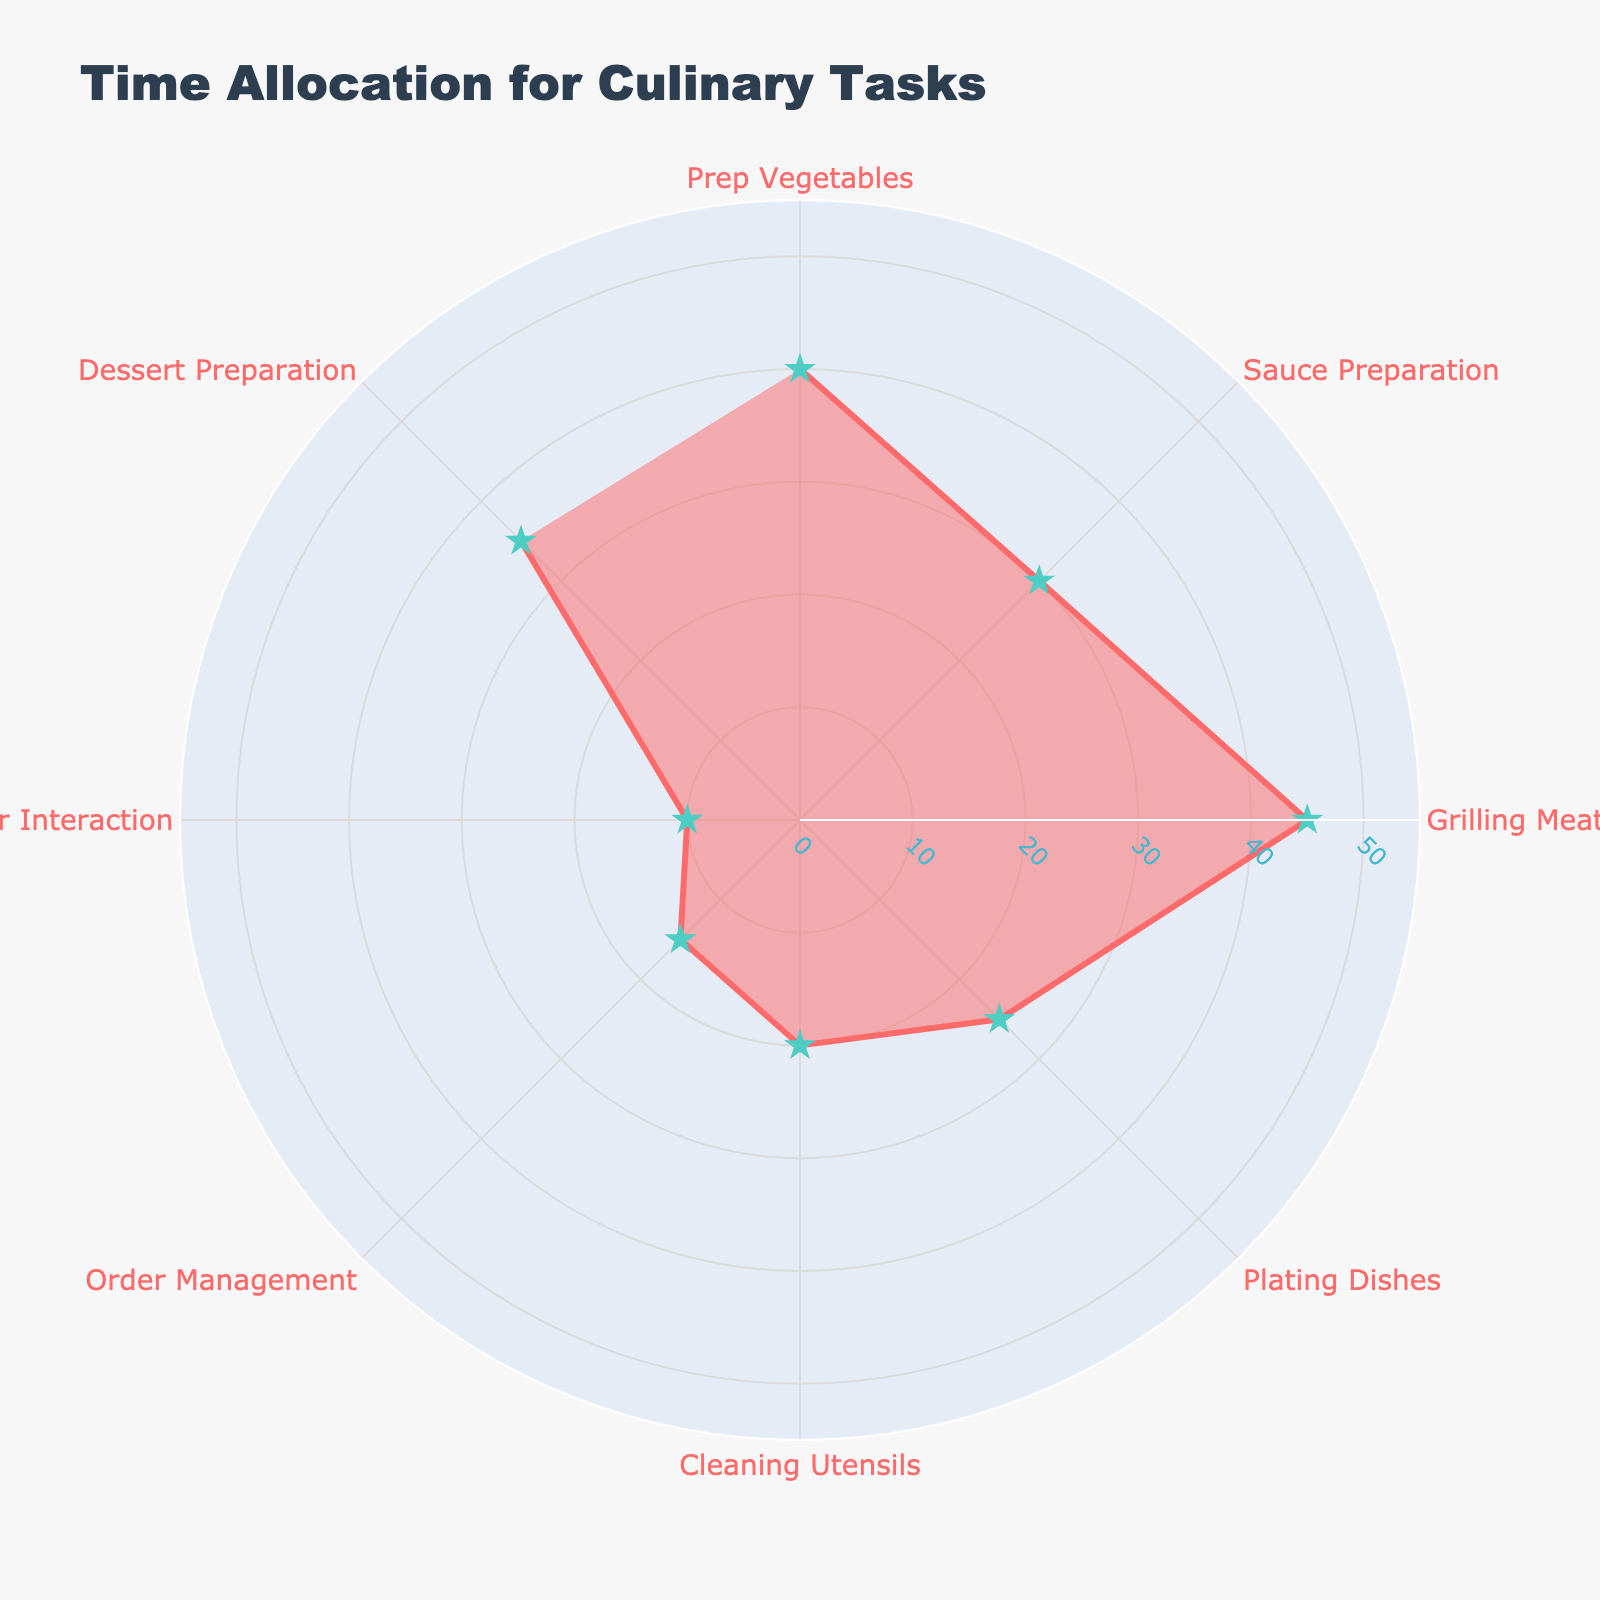What's the title of the chart? The title is always displayed at the top of the chart. In this case, it shows "Time Allocation for Culinary Tasks".
Answer: Time Allocation for Culinary Tasks Which task takes the longest amount of time? The Polar Chart will show the distances from the center, and the task with the longest distance from the center represents the highest time. "Grilling Meat" is the task farthest from the center.
Answer: Grilling Meat How many tasks are represented in the figure? Count the distinct segments or points on the chart, as each one represents a different task. There are 8 tasks shown.
Answer: 8 What is the time allocated for dessert preparation? Refer to the specific point representing "Dessert Preparation" on the chart which shows the radial distance. It is 35 minutes.
Answer: 35 minutes What is the average time spent on 'Prep Vegetables' and 'Cleaning Utensils'? Add the times for 'Prep Vegetables' (40 minutes) and 'Cleaning Utensils' (20 minutes), then divide by 2. The average is (40 + 20) / 2 = 30 minutes.
Answer: 30 minutes Which task takes less time than 'Plating Dishes' but more time than 'Customer Interaction'? Identify the tasks whose times are in between 'Plating Dishes' (25 minutes) and 'Customer Interaction' (10 minutes). 'Order Management' is the task that fits this criterion with 15 minutes.
Answer: Order Management What is the combined time spent on 'Sauce Preparation' and 'Dessert Preparation'? Add the times for 'Sauce Preparation' (30 minutes) and 'Dessert Preparation' (35 minutes). The sum is 30 + 35 = 65 minutes.
Answer: 65 minutes Which task takes exactly 45 minutes? Look for the point that lies on the circle marking 45 minutes. The task corresponding to this point will be 'Grilling Meat'.
Answer: Grilling Meat Which is shorter in duration: order management or customer interaction? Compare the radial distances for 'Order Management' (15 minutes) and 'Customer Interaction' (10 minutes). 'Customer Interaction' is shorter.
Answer: Customer Interaction What's the difference in time allocation between 'Prep Vegetables' and 'Order Management'? Subtract the time for 'Order Management' from 'Prep Vegetables'. 40 minutes (Prep Vegetables) - 15 minutes (Order Management) = 25 minutes.
Answer: 25 minutes 